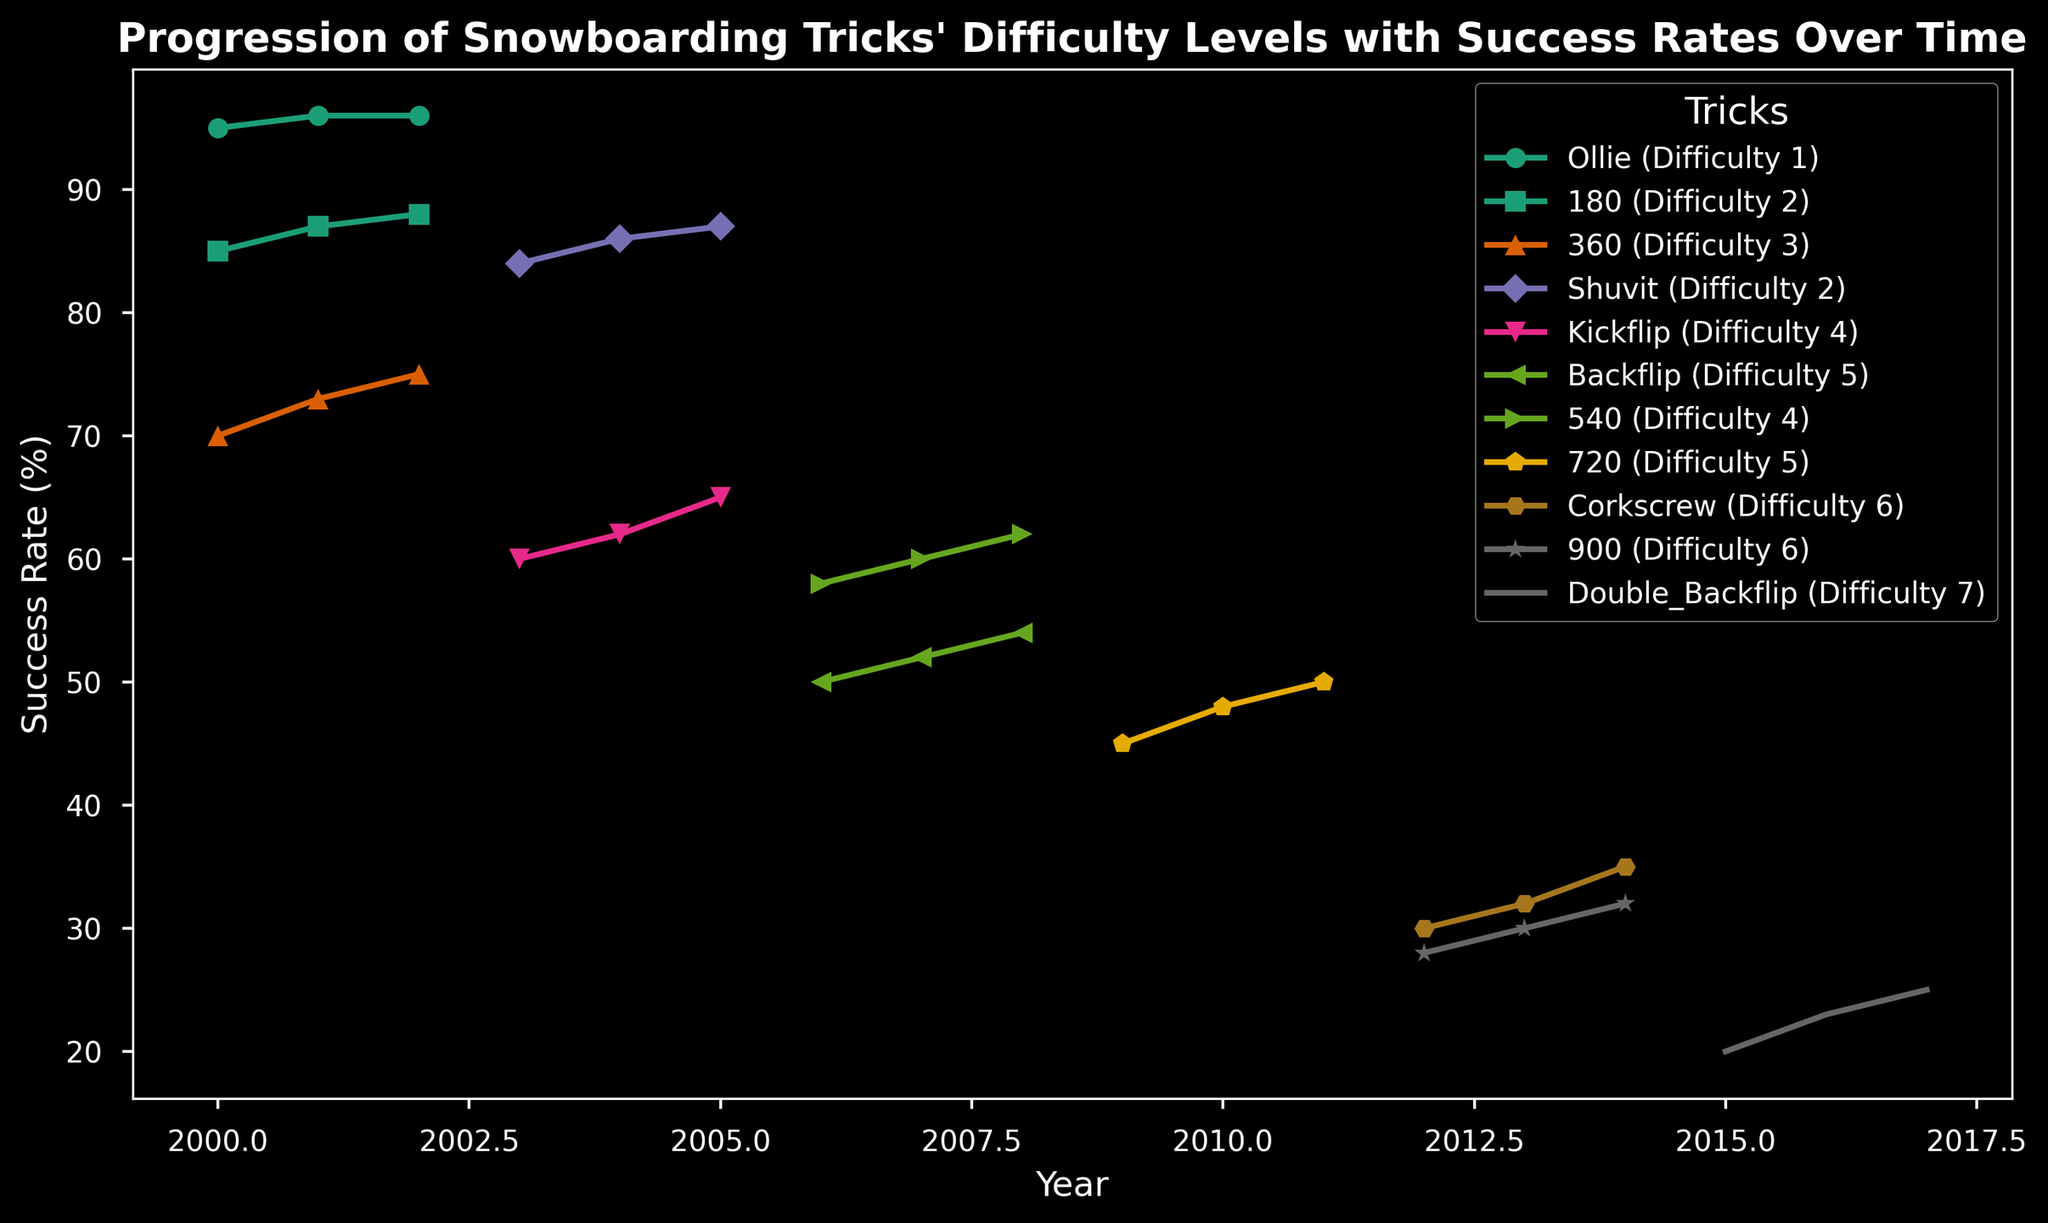Which trick has the highest success rate in the year 2000? In the plot, look at the lines representing different tricks for the year 2000 and find the one with the highest success rate. The Ollie trick has a success rate of 95%, which is the highest for that year.
Answer: Ollie Which trick showed the greatest improvement in success rate between its initial and final year? To answer this, calculate the difference between the initial and final success rates for each trick and find the one with the largest increase. The 360 trick improved from 70% in 2000 to 75% in 2002, showing a 5% increase.
Answer: 360 Which trick has the lowest success rate in its initial year? Look at the initial years of all tricks and identify which one has the lowest success rate. The Double Backflip has the lowest initial success rate of 20% in 2015.
Answer: Double Backflip In which year did the Kickflip success rate surpass 60%? Locate the Kickflip line and determine the first year it surpasses the 60% success rate mark. According to the plot, the Kickflip surpasses 60% in 2004.
Answer: 2004 Compare the success rates of the 540 and Ollie tricks in the year 2008. Which one is higher? Observe the 540 and Ollie lines in the year 2008 to compare their success rates. The 540 trick has a success rate of 62%, while Ollie is not plotted in 2008. Thus, 540 is higher.
Answer: 540 What is the average success rate of the Shuvit trick across all its plotted years? To compute the average, sum the success rates of the Shuvit trick from 2003 to 2005 (84 + 86 + 87) and then divide by the number of years (3). This results in (84 + 86 + 87) / 3 = 85.67%.
Answer: 85.67% Which tricks have a difficulty level of 5 and how do their success rates compare in 2010? Identify tricks with a difficulty level of 5 and check their success rates in 2010. The Backflip and 720 tricks have this level. The Backflip is not plotted in 2010, while the 720 has a success rate of 48%.
Answer: 720: 48% How did the success rate of the 180 trick change from 2000 to 2002? Calculate the difference in success rates for the 180 trick from 2000 to 2002. The success rate increased from 85% to 88%, a 3% improvement.
Answer: Increased by 3% What is the trend in the success rate of the Corkscrew trick from 2012 to 2014? Observe the Corkscrew line from 2012 to 2014. The success rate gradually increases from 30% in 2012 to 35% in 2014.
Answer: Increasing trend Between the years 2006 and 2008, which trick showed consistent improvement in success rates? Look at the lines from 2006 to 2008 and identify the trick(s) that show a consistent upward trend. Both Backflip and 540 show consistent improvement, but the 540 trick is explicitly plotted for each year with increasing rates of 58%, 60%, and 62%.
Answer: 540 